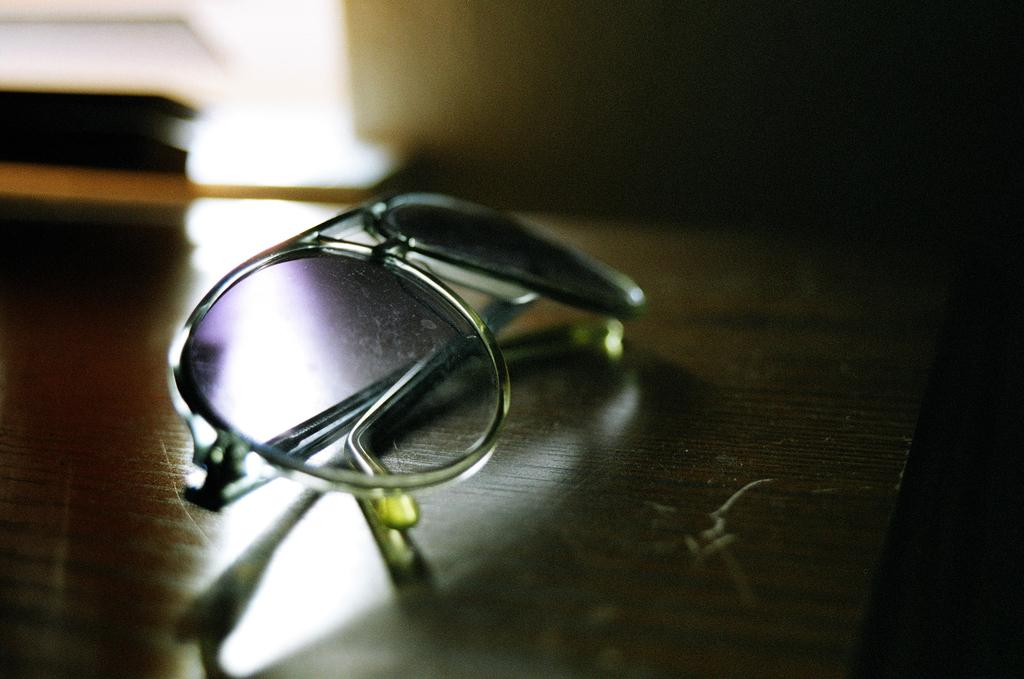What type of object is in the image? There are goggles in the image. Where are the goggles located? The goggles are placed on a wooden table. Can you describe the background of the image? The background of the image appears blurry. What type of pancake is being prepared by the laborer in the image? There is no laborer or pancake present in the image; it only features goggles on a wooden table. Can you describe the frog's behavior in the image? There is no frog present in the image. 